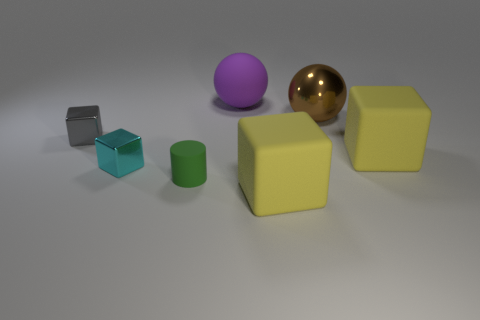Subtract all small gray metal blocks. How many blocks are left? 3 Add 1 gray metal blocks. How many objects exist? 8 Subtract all cyan cubes. How many cubes are left? 3 Add 7 small cylinders. How many small cylinders exist? 8 Subtract 0 purple cylinders. How many objects are left? 7 Subtract all blocks. How many objects are left? 3 Subtract 2 spheres. How many spheres are left? 0 Subtract all purple cylinders. Subtract all brown balls. How many cylinders are left? 1 Subtract all brown balls. How many cyan blocks are left? 1 Subtract all small metal things. Subtract all small brown balls. How many objects are left? 5 